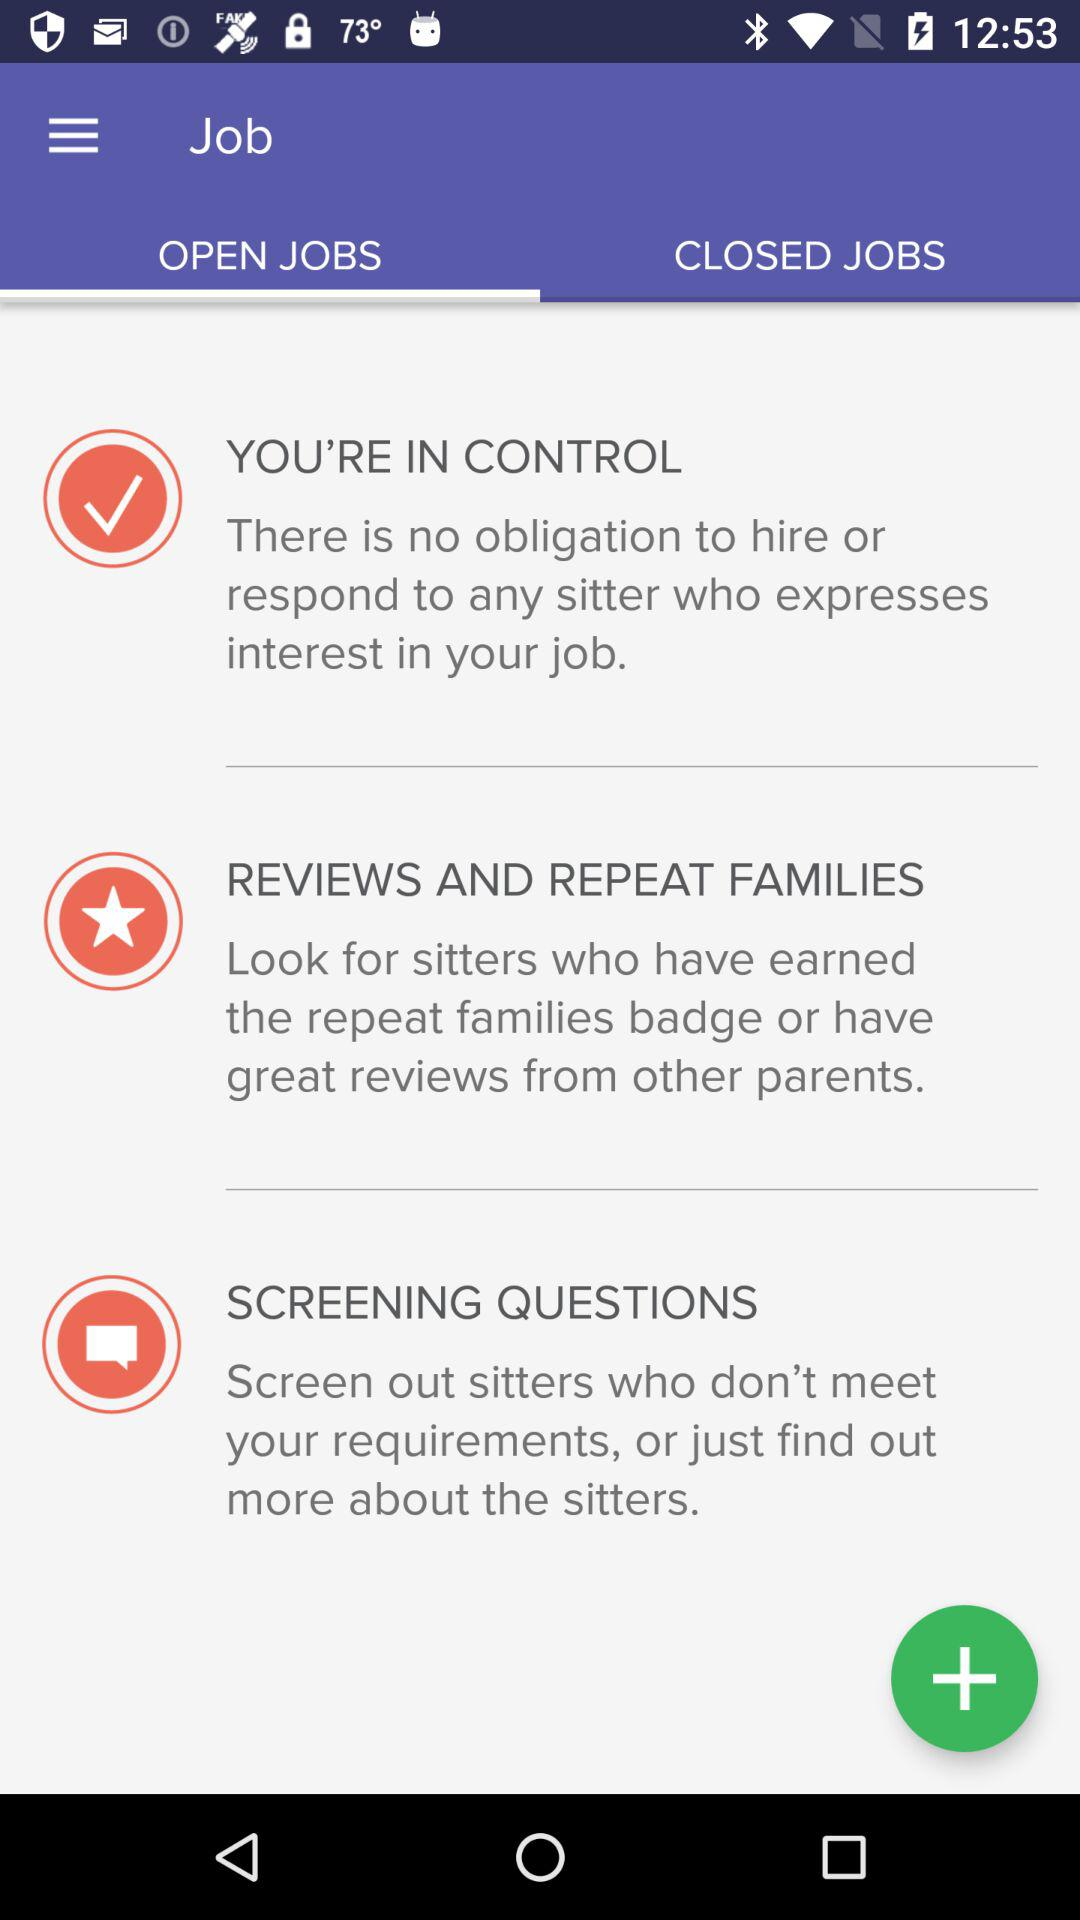What are the listed closed jobs?
When the provided information is insufficient, respond with <no answer>. <no answer> 